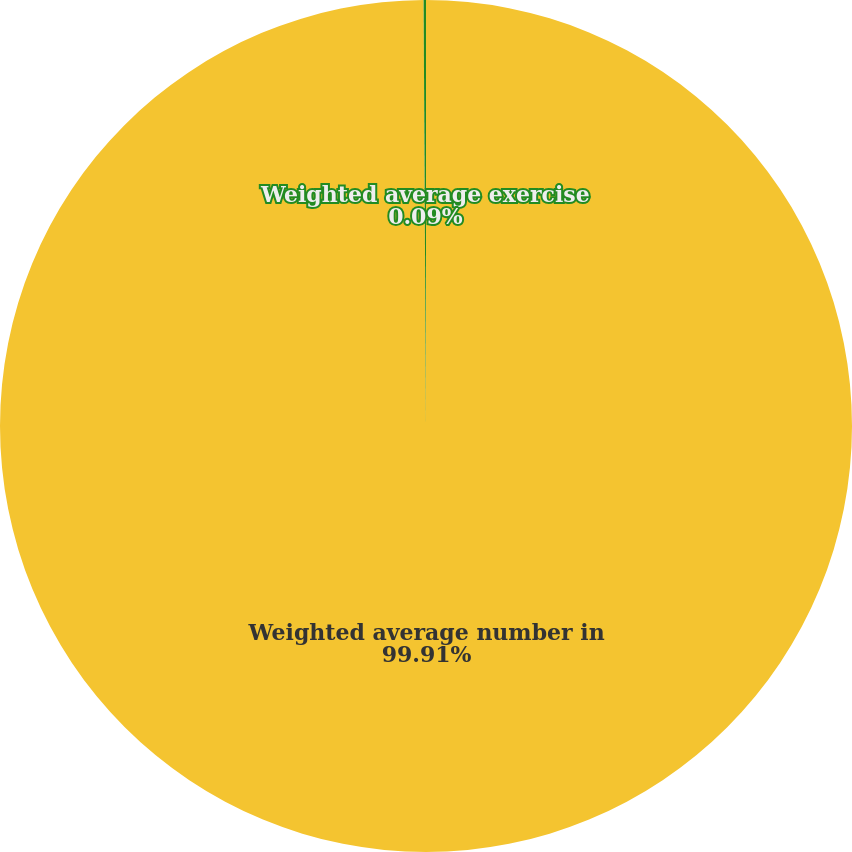Convert chart to OTSL. <chart><loc_0><loc_0><loc_500><loc_500><pie_chart><fcel>Weighted average number in<fcel>Weighted average exercise<nl><fcel>99.91%<fcel>0.09%<nl></chart> 